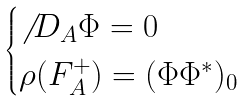Convert formula to latex. <formula><loc_0><loc_0><loc_500><loc_500>\begin{cases} \not \, { D } _ { A } \Phi = 0 \\ \rho ( F _ { A } ^ { + } ) = ( \Phi \Phi ^ { * } ) _ { 0 } \end{cases}</formula> 